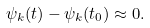<formula> <loc_0><loc_0><loc_500><loc_500>\psi _ { k } ( t ) - \psi _ { k } ( t _ { 0 } ) \approx 0 .</formula> 